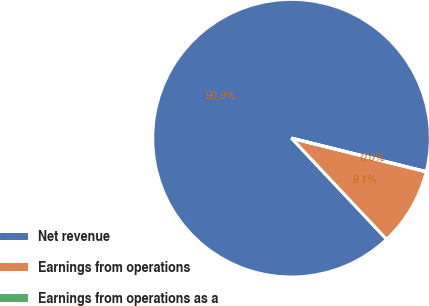Convert chart to OTSL. <chart><loc_0><loc_0><loc_500><loc_500><pie_chart><fcel>Net revenue<fcel>Earnings from operations<fcel>Earnings from operations as a<nl><fcel>90.89%<fcel>9.1%<fcel>0.01%<nl></chart> 